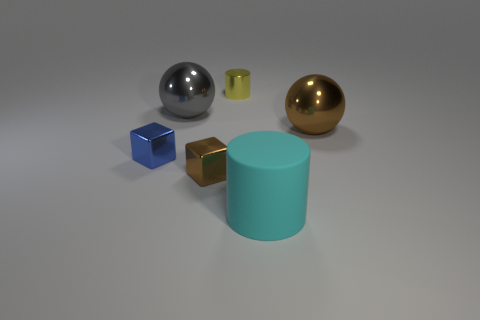Is there any other thing that is the same material as the big cyan thing?
Make the answer very short. No. How many objects are to the right of the gray object and behind the big brown object?
Your answer should be very brief. 1. What number of big cylinders are in front of the big object that is left of the large cyan matte thing?
Keep it short and to the point. 1. There is a block that is in front of the blue thing; is its size the same as the metallic ball that is to the left of the yellow cylinder?
Give a very brief answer. No. How many large metal things are there?
Your answer should be compact. 2. What number of tiny yellow cylinders have the same material as the blue object?
Your answer should be very brief. 1. Are there the same number of large cyan matte cylinders that are behind the cyan matte cylinder and blue rubber cubes?
Your answer should be compact. Yes. There is a brown shiny sphere; is it the same size as the ball that is to the left of the large cyan cylinder?
Keep it short and to the point. Yes. How many other things are the same size as the brown block?
Keep it short and to the point. 2. Is the yellow metallic thing the same size as the blue block?
Your answer should be very brief. Yes. 